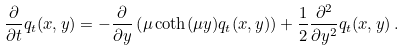Convert formula to latex. <formula><loc_0><loc_0><loc_500><loc_500>\frac { \partial } { \partial t } q _ { t } ( x , y ) = - \frac { \partial } { \partial y } \left ( \mu \coth ( \mu y ) q _ { t } ( x , y ) \right ) + \frac { 1 } { 2 } \frac { \partial ^ { 2 } } { \partial y ^ { 2 } } q _ { t } ( x , y ) \, .</formula> 